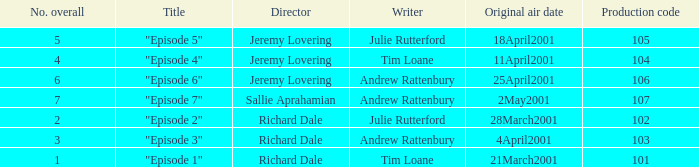When did the episode first air that had a production code of 102? 28March2001. 